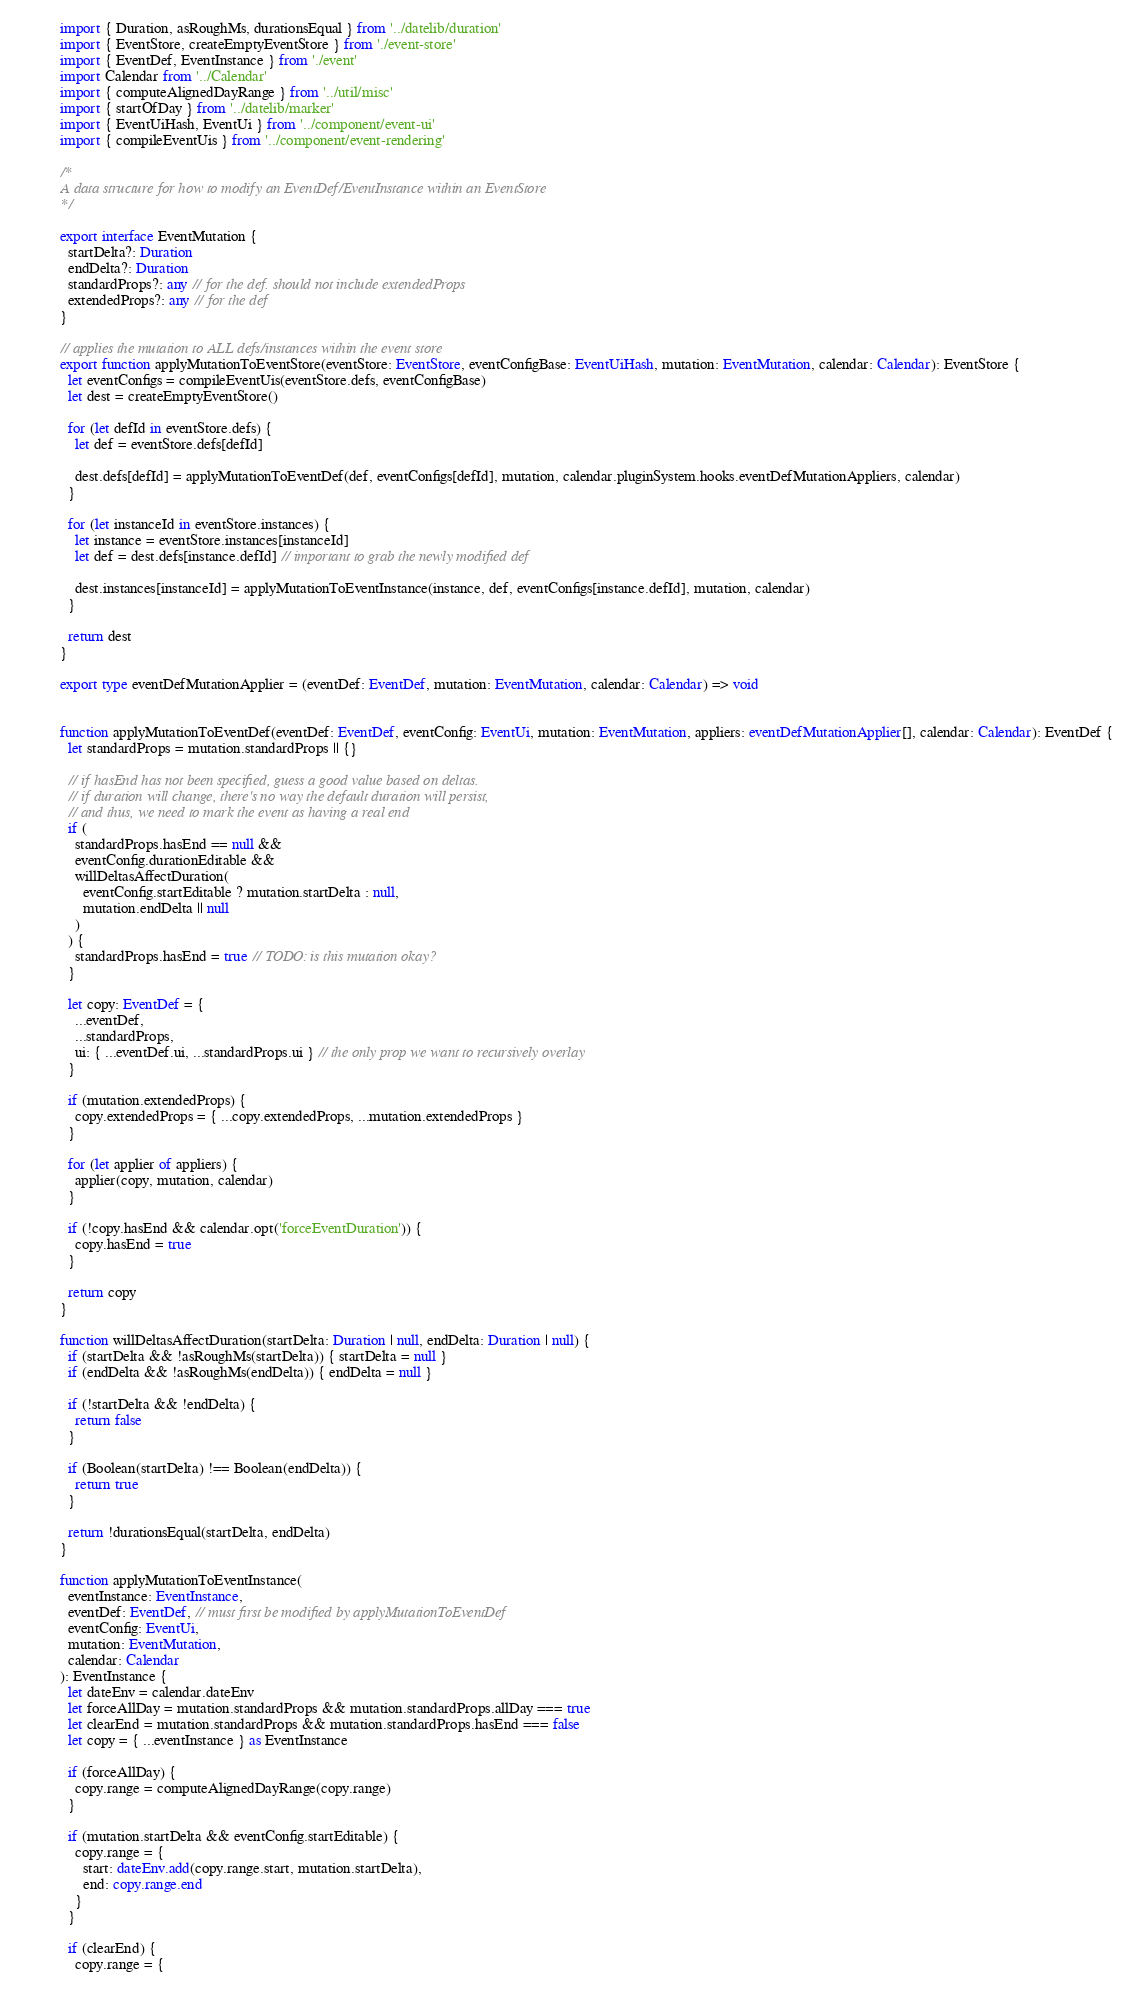Convert code to text. <code><loc_0><loc_0><loc_500><loc_500><_TypeScript_>import { Duration, asRoughMs, durationsEqual } from '../datelib/duration'
import { EventStore, createEmptyEventStore } from './event-store'
import { EventDef, EventInstance } from './event'
import Calendar from '../Calendar'
import { computeAlignedDayRange } from '../util/misc'
import { startOfDay } from '../datelib/marker'
import { EventUiHash, EventUi } from '../component/event-ui'
import { compileEventUis } from '../component/event-rendering'

/*
A data structure for how to modify an EventDef/EventInstance within an EventStore
*/

export interface EventMutation {
  startDelta?: Duration
  endDelta?: Duration
  standardProps?: any // for the def. should not include extendedProps
  extendedProps?: any // for the def
}

// applies the mutation to ALL defs/instances within the event store
export function applyMutationToEventStore(eventStore: EventStore, eventConfigBase: EventUiHash, mutation: EventMutation, calendar: Calendar): EventStore {
  let eventConfigs = compileEventUis(eventStore.defs, eventConfigBase)
  let dest = createEmptyEventStore()

  for (let defId in eventStore.defs) {
    let def = eventStore.defs[defId]

    dest.defs[defId] = applyMutationToEventDef(def, eventConfigs[defId], mutation, calendar.pluginSystem.hooks.eventDefMutationAppliers, calendar)
  }

  for (let instanceId in eventStore.instances) {
    let instance = eventStore.instances[instanceId]
    let def = dest.defs[instance.defId] // important to grab the newly modified def

    dest.instances[instanceId] = applyMutationToEventInstance(instance, def, eventConfigs[instance.defId], mutation, calendar)
  }

  return dest
}

export type eventDefMutationApplier = (eventDef: EventDef, mutation: EventMutation, calendar: Calendar) => void


function applyMutationToEventDef(eventDef: EventDef, eventConfig: EventUi, mutation: EventMutation, appliers: eventDefMutationApplier[], calendar: Calendar): EventDef {
  let standardProps = mutation.standardProps || {}

  // if hasEnd has not been specified, guess a good value based on deltas.
  // if duration will change, there's no way the default duration will persist,
  // and thus, we need to mark the event as having a real end
  if (
    standardProps.hasEnd == null &&
    eventConfig.durationEditable &&
    willDeltasAffectDuration(
      eventConfig.startEditable ? mutation.startDelta : null,
      mutation.endDelta || null
    )
  ) {
    standardProps.hasEnd = true // TODO: is this mutation okay?
  }

  let copy: EventDef = {
    ...eventDef,
    ...standardProps,
    ui: { ...eventDef.ui, ...standardProps.ui } // the only prop we want to recursively overlay
  }

  if (mutation.extendedProps) {
    copy.extendedProps = { ...copy.extendedProps, ...mutation.extendedProps }
  }

  for (let applier of appliers) {
    applier(copy, mutation, calendar)
  }

  if (!copy.hasEnd && calendar.opt('forceEventDuration')) {
    copy.hasEnd = true
  }

  return copy
}

function willDeltasAffectDuration(startDelta: Duration | null, endDelta: Duration | null) {
  if (startDelta && !asRoughMs(startDelta)) { startDelta = null }
  if (endDelta && !asRoughMs(endDelta)) { endDelta = null }

  if (!startDelta && !endDelta) {
    return false
  }

  if (Boolean(startDelta) !== Boolean(endDelta)) {
    return true
  }

  return !durationsEqual(startDelta, endDelta)
}

function applyMutationToEventInstance(
  eventInstance: EventInstance,
  eventDef: EventDef, // must first be modified by applyMutationToEventDef
  eventConfig: EventUi,
  mutation: EventMutation,
  calendar: Calendar
): EventInstance {
  let dateEnv = calendar.dateEnv
  let forceAllDay = mutation.standardProps && mutation.standardProps.allDay === true
  let clearEnd = mutation.standardProps && mutation.standardProps.hasEnd === false
  let copy = { ...eventInstance } as EventInstance

  if (forceAllDay) {
    copy.range = computeAlignedDayRange(copy.range)
  }

  if (mutation.startDelta && eventConfig.startEditable) {
    copy.range = {
      start: dateEnv.add(copy.range.start, mutation.startDelta),
      end: copy.range.end
    }
  }

  if (clearEnd) {
    copy.range = {</code> 